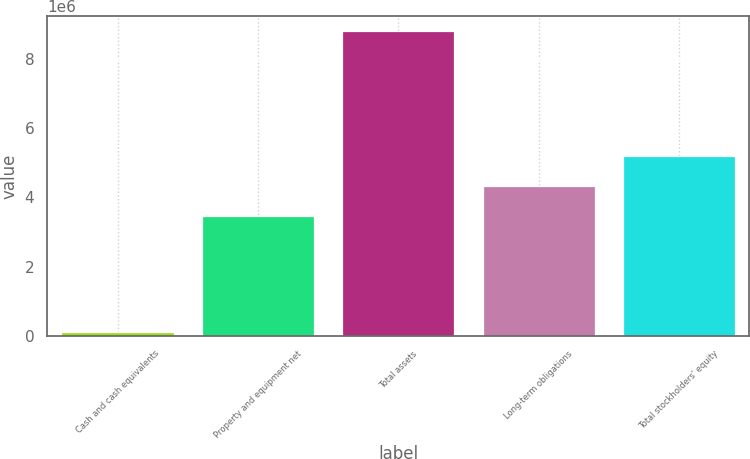Convert chart. <chart><loc_0><loc_0><loc_500><loc_500><bar_chart><fcel>Cash and cash equivalents<fcel>Property and equipment net<fcel>Total assets<fcel>Long-term obligations<fcel>Total stockholders' equity<nl><fcel>112701<fcel>3.46053e+06<fcel>8.78685e+06<fcel>4.32794e+06<fcel>5.19536e+06<nl></chart> 